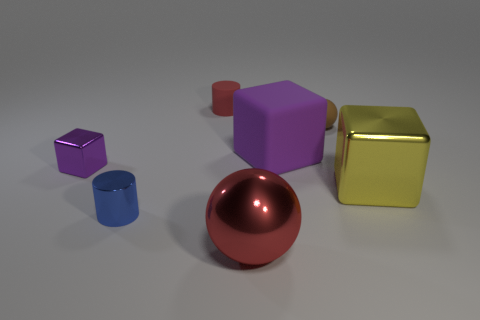There is a large object behind the large yellow thing; what shape is it?
Keep it short and to the point. Cube. How many other objects are there of the same material as the big purple block?
Make the answer very short. 2. Do the tiny rubber ball and the tiny block have the same color?
Your response must be concise. No. Are there fewer big yellow things left of the tiny purple shiny block than big yellow objects that are in front of the small red cylinder?
Offer a terse response. Yes. What color is the other shiny thing that is the same shape as the large yellow shiny thing?
Keep it short and to the point. Purple. There is a red object that is behind the yellow cube; does it have the same size as the tiny shiny cube?
Keep it short and to the point. Yes. Are there fewer large metal balls in front of the red ball than big blue rubber cylinders?
Give a very brief answer. No. Is there any other thing that is the same size as the purple metallic cube?
Offer a terse response. Yes. What size is the ball on the right side of the purple thing right of the small blue thing?
Ensure brevity in your answer.  Small. Are there any other things that have the same shape as the big purple matte object?
Make the answer very short. Yes. 